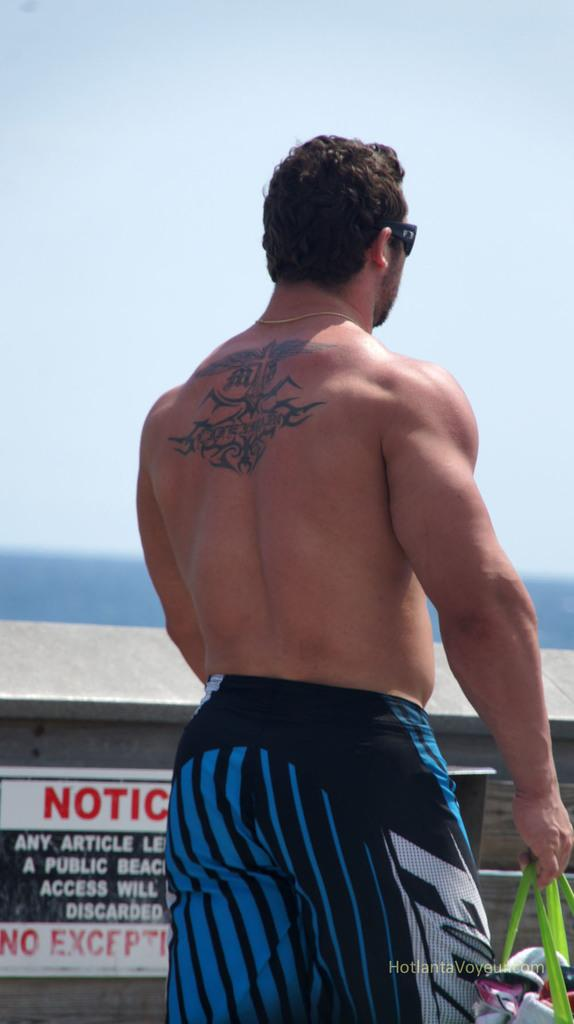Provide a one-sentence caption for the provided image. shirtless man with back tattoo in front of a notice sign on the fence. 